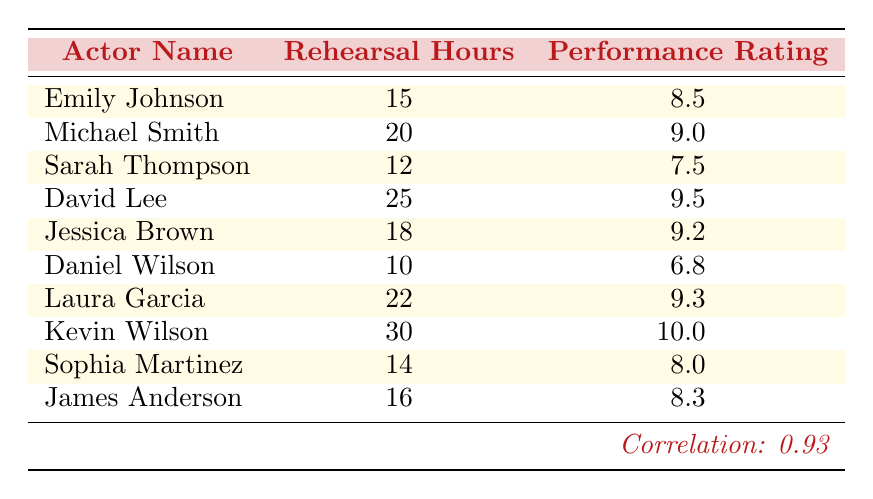What is the performance rating of Kevin Wilson? You can find Kevin Wilson's name in the table, and his performance rating is listed right next to it. According to the table, Kevin Wilson has a performance rating of 10.0.
Answer: 10.0 How many rehearsal hours did David Lee log? David Lee's rehearsal hours are shown in the table next to his name. The table indicates that David Lee logged 25 rehearsal hours.
Answer: 25 Is Jessica Brown's performance rating higher than Emily Johnson's? To answer this question, compare the performance ratings for Jessica Brown and Emily Johnson. The table shows that Jessica Brown has a rating of 9.2 and Emily Johnson has 8.5. Since 9.2 is greater than 8.5, Jessica Brown's performance rating is indeed higher.
Answer: Yes What is the average performance rating of all actors? First, we need to sum the performance ratings: 8.5 + 9.0 + 7.5 + 9.5 + 9.2 + 6.8 + 9.3 + 10.0 + 8.0 + 8.3 = 81.1. There are 10 actors, so we divide the total by 10, which gives us 81.1 / 10 = 8.11.
Answer: 8.1 How many actors have a performance rating above 9.0? We need to count the number of performance ratings that are greater than 9.0. From the table, the actors with ratings above 9.0 are Michael Smith (9.0), David Lee (9.5), Jessica Brown (9.2), Laura Garcia (9.3), and Kevin Wilson (10.0). Counting these, we see there are 4 actors.
Answer: 4 What is the difference in rehearsal hours between the actor with the highest rating and the actor with the lowest rating? First, identify the highest and lowest performance ratings from the table. Kevin Wilson has the highest rating (10.0) and Daniel Wilson has the lowest (6.8). The rehearsal hours for Kevin are 30 and for Daniel are 10. The difference is 30 - 10 = 20 hours.
Answer: 20 Is it true that more rehearsal hours consistently correlate with better performance ratings? The correlation value provided in the table is 0.93, which indicates a strong positive correlation between rehearsal hours and performance ratings. A correlation close to 1 suggests that as rehearsal hours increase, performance ratings also tend to increase, supporting the idea that more rehearsal hours correlate with better performance.
Answer: Yes Which actor had the least amount of rehearsal hours, and what was their performance rating? Looking at the rehearsal hours in the table, Daniel Wilson has the least with 10 hours. Next to his name, the performance rating listed is 6.8.
Answer: Daniel Wilson, 6.8 